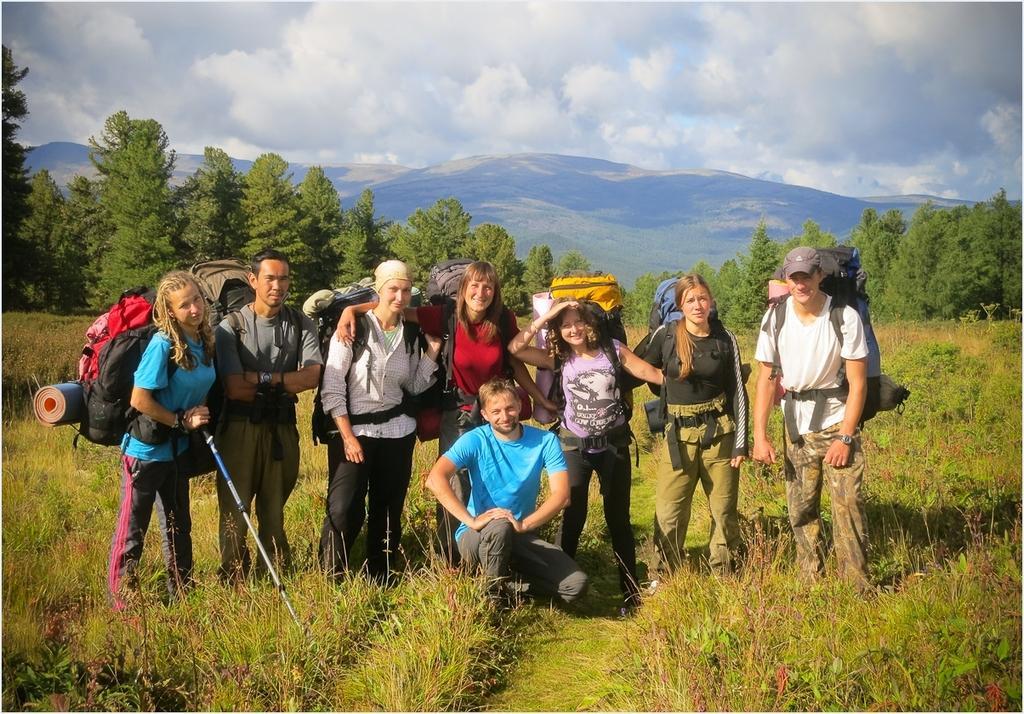Describe this image in one or two sentences. In this image I can see group of people standing, in front the person is sitting wearing blue shirt, gray pant. I can also see few bags in multi color, background I can see trees and grass in green color and the sky is in blue and white color. 